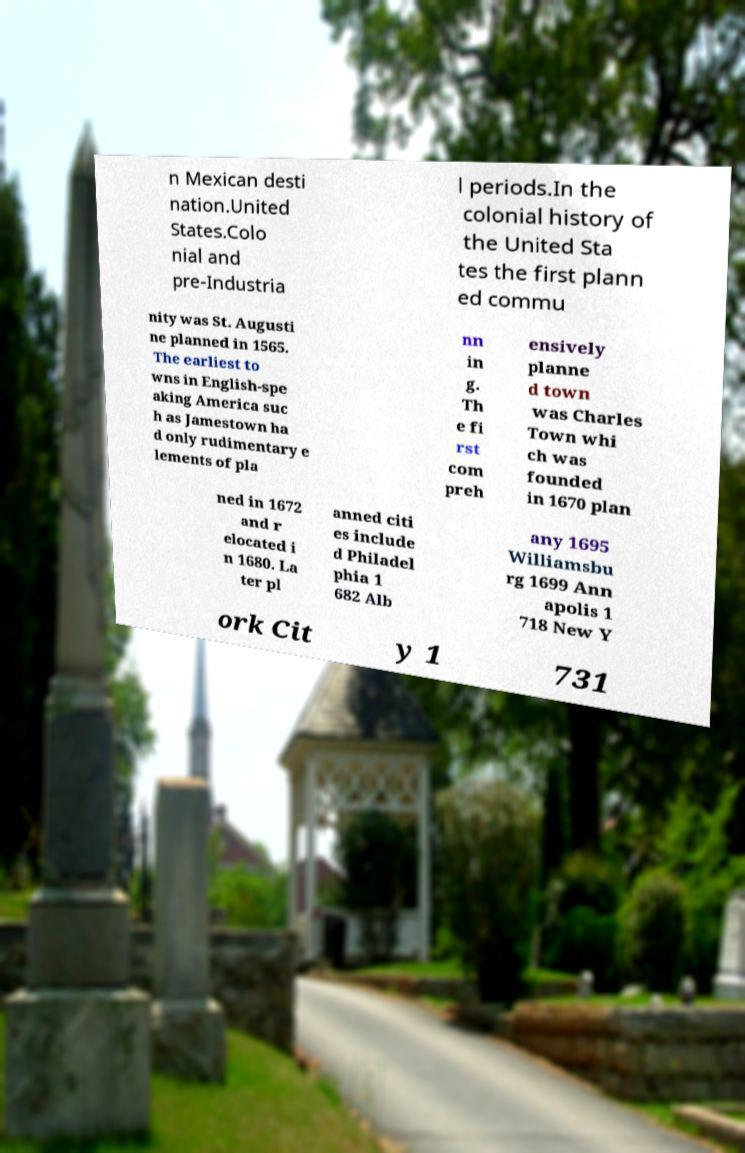I need the written content from this picture converted into text. Can you do that? n Mexican desti nation.United States.Colo nial and pre-Industria l periods.In the colonial history of the United Sta tes the first plann ed commu nity was St. Augusti ne planned in 1565. The earliest to wns in English-spe aking America suc h as Jamestown ha d only rudimentary e lements of pla nn in g. Th e fi rst com preh ensively planne d town was Charles Town whi ch was founded in 1670 plan ned in 1672 and r elocated i n 1680. La ter pl anned citi es include d Philadel phia 1 682 Alb any 1695 Williamsbu rg 1699 Ann apolis 1 718 New Y ork Cit y 1 731 